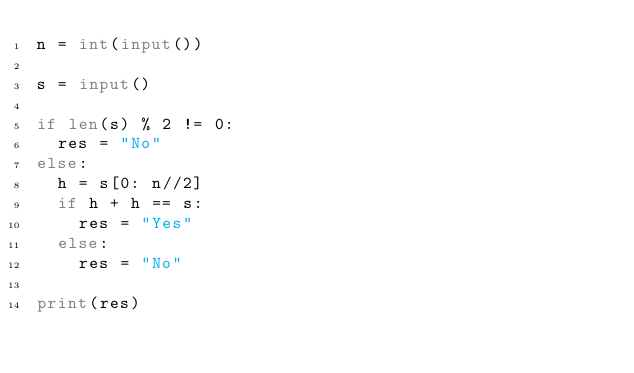Convert code to text. <code><loc_0><loc_0><loc_500><loc_500><_Python_>n = int(input())

s = input()

if len(s) % 2 != 0:
  res = "No"
else:
  h = s[0: n//2]
  if h + h == s:
    res = "Yes"
  else:
    res = "No"

print(res)</code> 